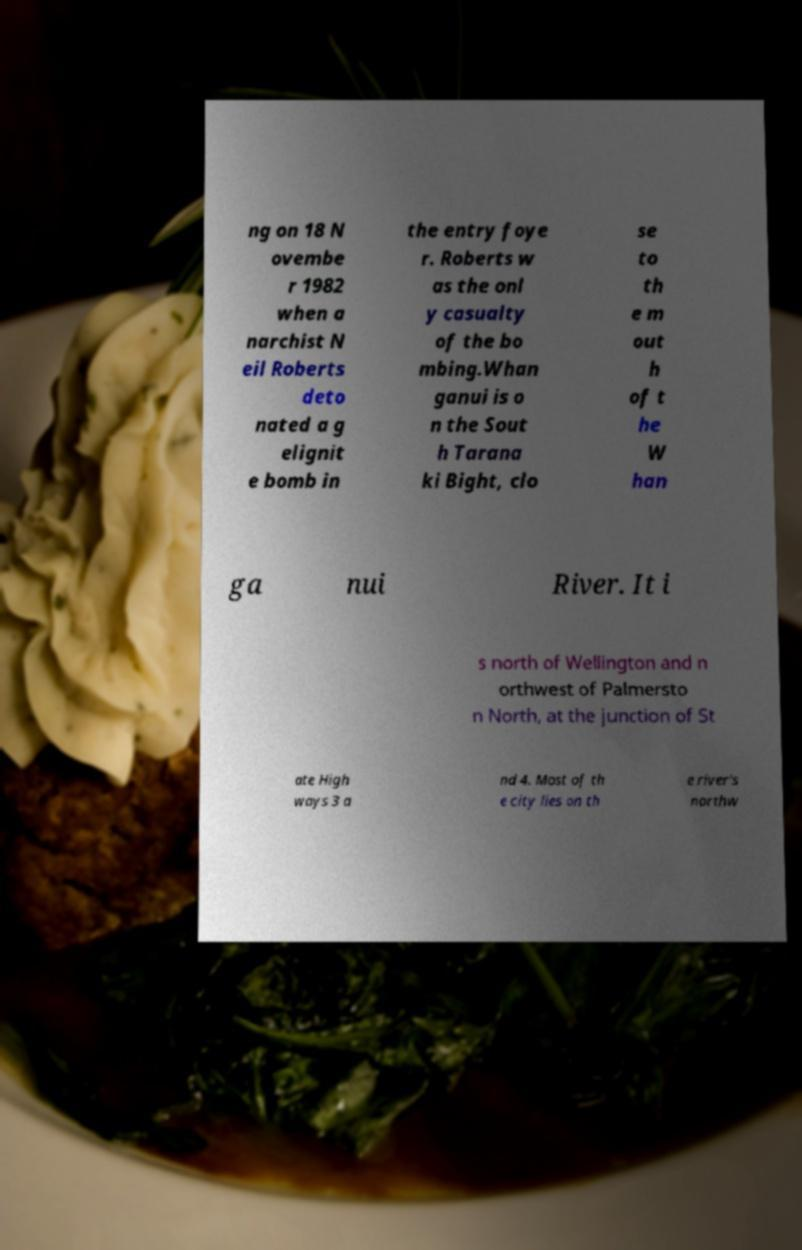Please read and relay the text visible in this image. What does it say? ng on 18 N ovembe r 1982 when a narchist N eil Roberts deto nated a g elignit e bomb in the entry foye r. Roberts w as the onl y casualty of the bo mbing.Whan ganui is o n the Sout h Tarana ki Bight, clo se to th e m out h of t he W han ga nui River. It i s north of Wellington and n orthwest of Palmersto n North, at the junction of St ate High ways 3 a nd 4. Most of th e city lies on th e river's northw 